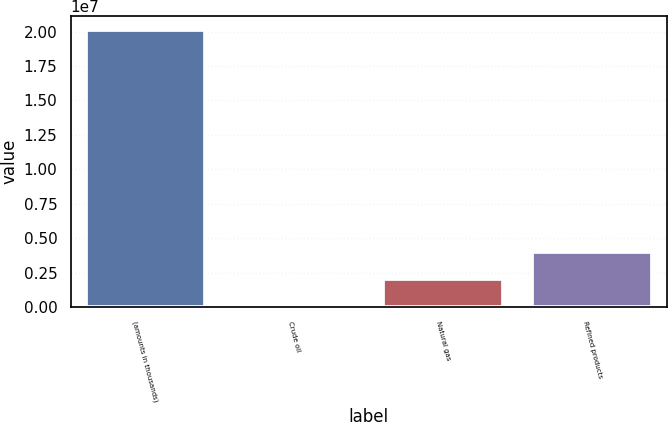<chart> <loc_0><loc_0><loc_500><loc_500><bar_chart><fcel>(amounts in thousands)<fcel>Crude oil<fcel>Natural gas<fcel>Refined products<nl><fcel>2.0112e+07<fcel>5<fcel>2.01121e+06<fcel>4.02241e+06<nl></chart> 